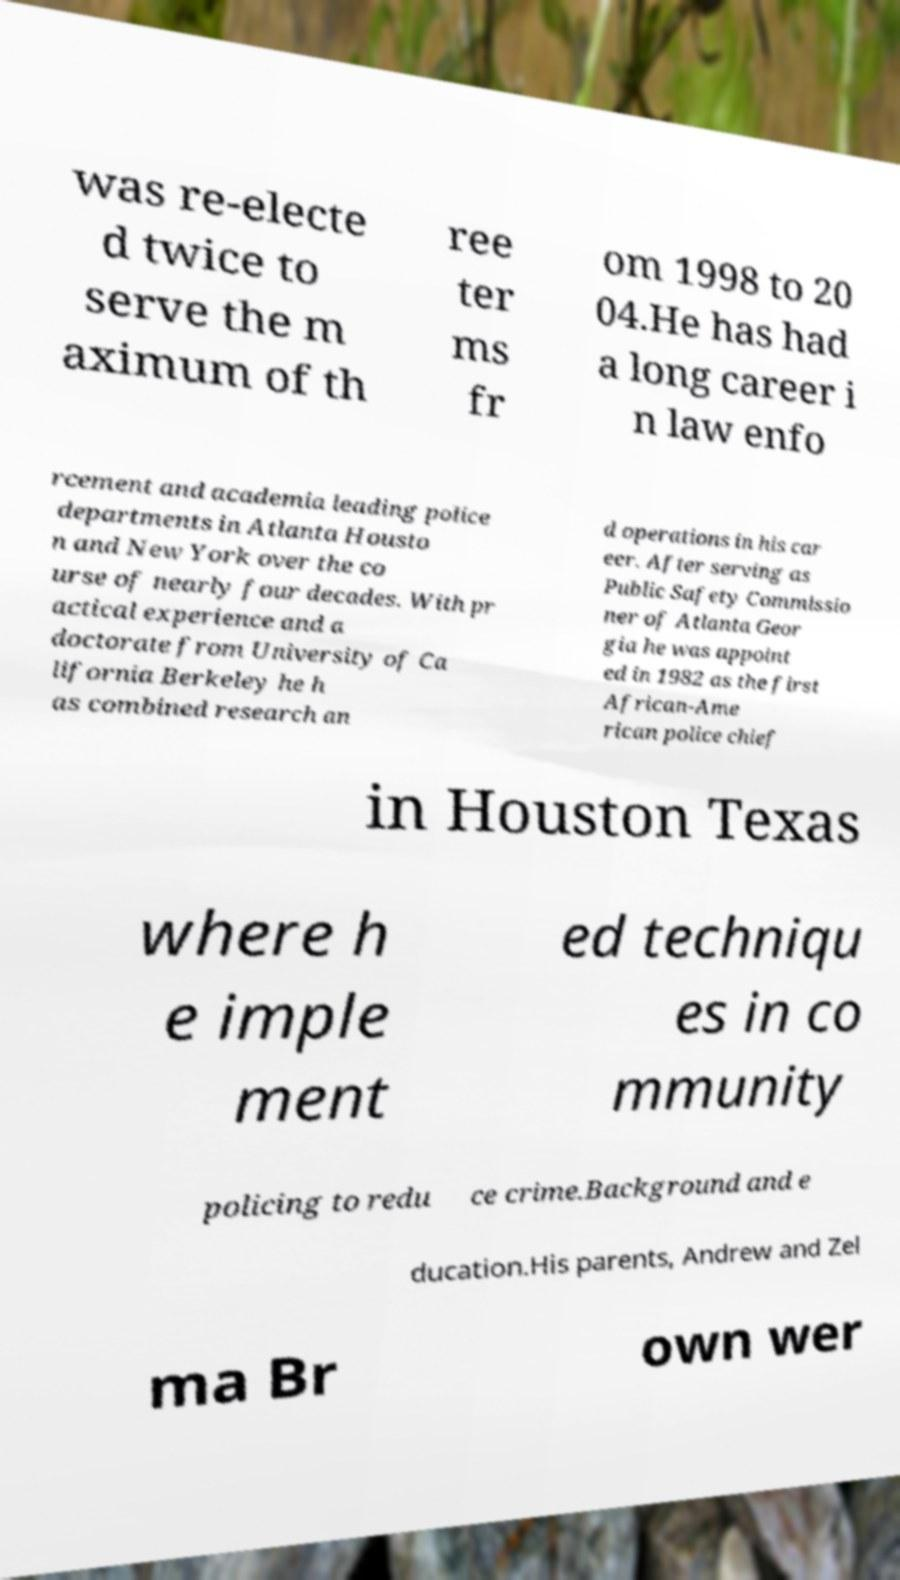I need the written content from this picture converted into text. Can you do that? was re-electe d twice to serve the m aximum of th ree ter ms fr om 1998 to 20 04.He has had a long career i n law enfo rcement and academia leading police departments in Atlanta Housto n and New York over the co urse of nearly four decades. With pr actical experience and a doctorate from University of Ca lifornia Berkeley he h as combined research an d operations in his car eer. After serving as Public Safety Commissio ner of Atlanta Geor gia he was appoint ed in 1982 as the first African-Ame rican police chief in Houston Texas where h e imple ment ed techniqu es in co mmunity policing to redu ce crime.Background and e ducation.His parents, Andrew and Zel ma Br own wer 